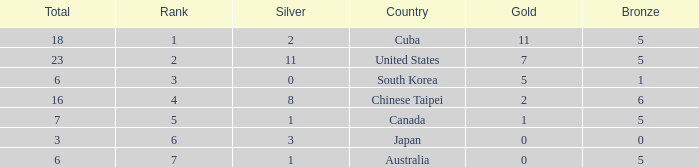What was the sum of the ranks for Japan who had less than 5 bronze medals and more than 3 silvers? None. 